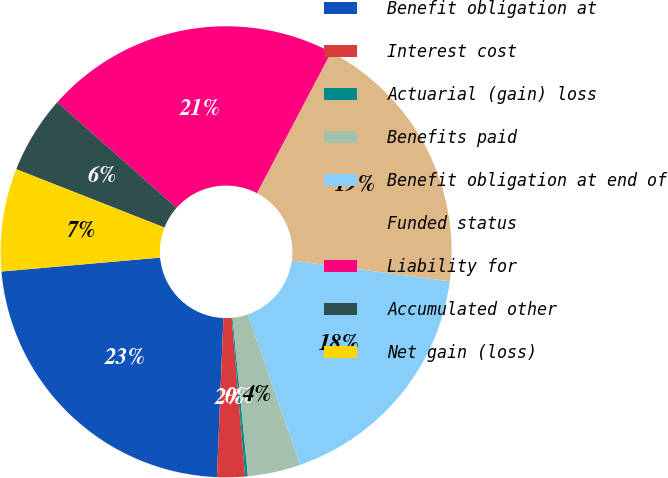<chart> <loc_0><loc_0><loc_500><loc_500><pie_chart><fcel>Benefit obligation at<fcel>Interest cost<fcel>Actuarial (gain) loss<fcel>Benefits paid<fcel>Benefit obligation at end of<fcel>Funded status<fcel>Liability for<fcel>Accumulated other<fcel>Net gain (loss)<nl><fcel>22.96%<fcel>1.99%<fcel>0.2%<fcel>3.78%<fcel>17.59%<fcel>19.38%<fcel>21.17%<fcel>5.57%<fcel>7.36%<nl></chart> 